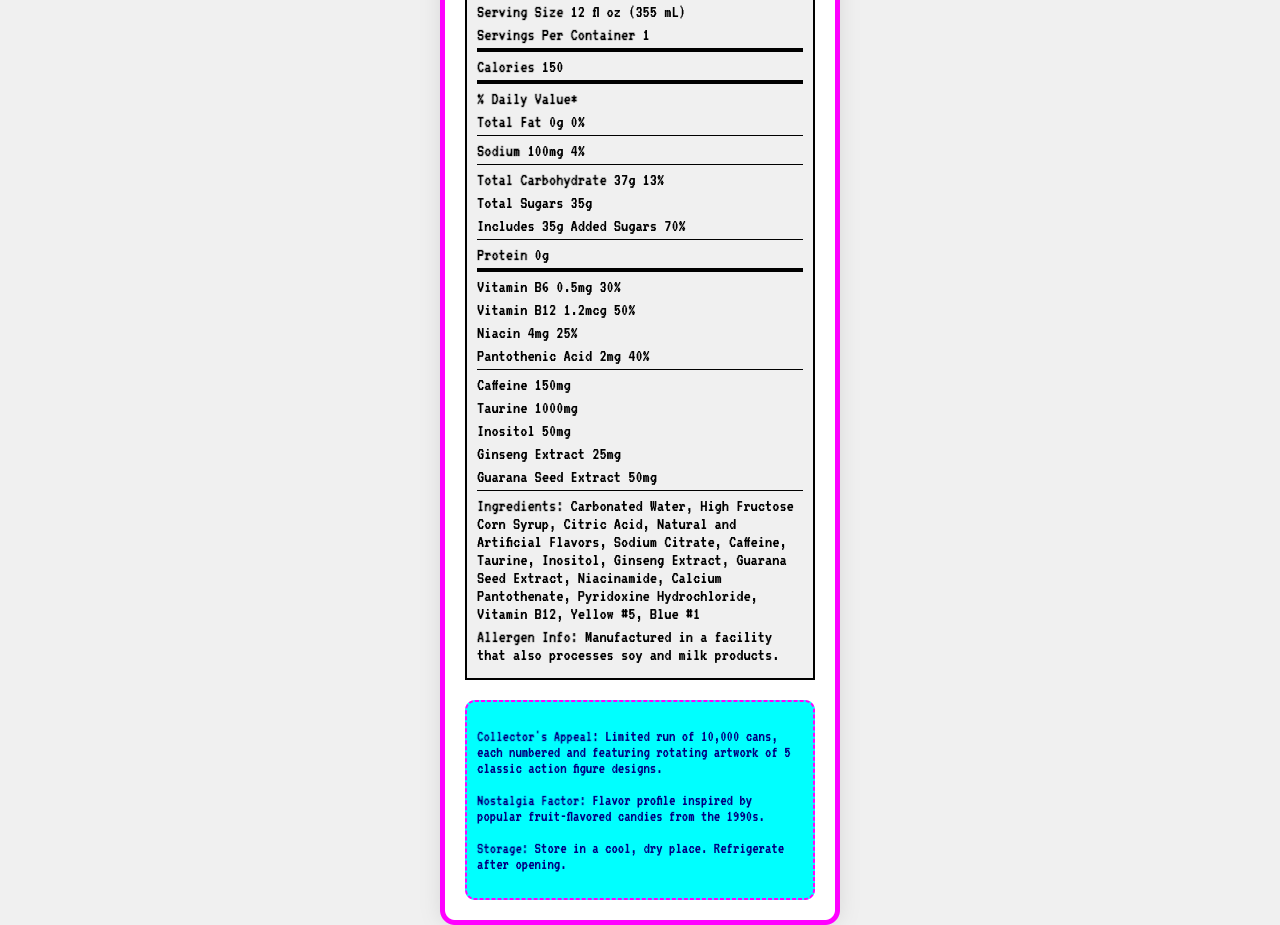what is the serving size? The serving size is specified at the beginning of the Nutrition Facts section.
Answer: 12 fl oz (355 mL) how many calories are in one serving of RetroZap Collector's Edition Energy Drink? The number of calories per serving is listed immediately after the serving size and servings per container.
Answer: 150 how much total fat is in the drink? The amount of total fat is listed in the % Daily Value section under Total Fat.
Answer: 0g what percentage of the daily recommended value of sodium does the drink provide? The % Daily Value for sodium is listed in the sodium section, which is 100mg or 4%.
Answer: 4% how much added sugar is in the drink? The amount of added sugar is listed under total sugars and is specified as 35g.
Answer: 35g which vitamin has the highest daily value percentage in the drink? A. Vitamin B6 B. Vitamin B12 C. Niacin D. Pantothenic Acid Vitamin B12 has a daily value of 50%, which is the highest among the vitamins listed.
Answer: B what is the main ingredient in RetroZap Collector's Edition Energy Drink? A. High Fructose Corn Syrup B. Carbonated Water C. Caffeine D. Taurine The first ingredient listed is Carbonated Water, which indicates it is the main ingredient.
Answer: B Does the drink contain any proteins? The Nutrition Facts section states that the drink contains 0g of protein.
Answer: No what is the caffeine content of the drink? The caffeine content is listed towards the bottom of the Nutrition Facts section and it is 150mg.
Answer: 150mg what are the storage instructions for the drink? The storage instructions are listed under the collector info section.
Answer: Store in a cool, dry place. Refrigerate after opening. Is the RetroZap Collector's Edition Energy Drink high in sodium? The drink provides only 4% of the daily recommended value of sodium, which is relatively low.
Answer: No summarize the main idea of the document. The document details the nutritional content, ingredients, allergen information, and collector's appeal of the RetroZap drink, highlighting its nostalgic value and limited availability.
Answer: The RetroZap Collector's Edition Energy Drink is a novelty energy drink marketed towards collectors and toy enthusiasts, offering nutritional information such as 150 calories, 0g fat, 100mg sodium, 37g carbohydrates, and various vitamins and stimulants like caffeine, taurine, and ginseng extract. It’s a limited-edition product with collectible packaging featuring vintage action figures, and comes with a chance to win rare toys. what is the flavor profile inspired by? The flavor profile is described in the nostalgia factor section as inspired by 1990s fruit-flavored candies.
Answer: Popular fruit-flavored candies from the 1990s how many servings are in each container? The servings per container information is listed at the beginning of the Nutrition Facts section, which is 1.
Answer: 1 what are some of the key ingredients in this drink? These are the first few ingredients listed in the ingredients section, indicating they are key components.
Answer: Carbonated Water, High Fructose Corn Syrup, Citric Acid, Natural and Artificial Flavors, Sodium Citrate, Caffeine, Taurine what is the limited run for the RetroZap Collector's Edition Energy Drink? The collector appeal section mentions the limited run of 10,000 cans.
Answer: 10,000 cans what’s the chance of winning rare, vintage toys upon purchasing the can? The document mentions a unique code for a chance to win rare, vintage toys but does not provide the actual odds of winning.
Answer: Cannot be determined 